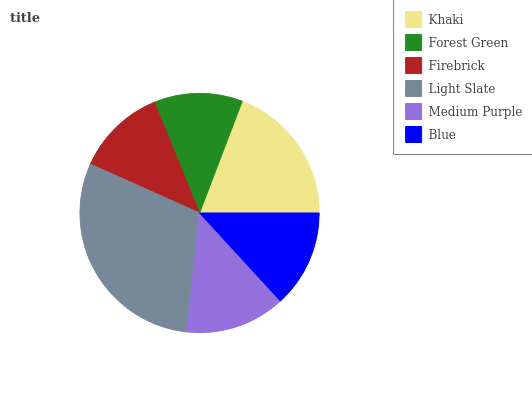Is Forest Green the minimum?
Answer yes or no. Yes. Is Light Slate the maximum?
Answer yes or no. Yes. Is Firebrick the minimum?
Answer yes or no. No. Is Firebrick the maximum?
Answer yes or no. No. Is Firebrick greater than Forest Green?
Answer yes or no. Yes. Is Forest Green less than Firebrick?
Answer yes or no. Yes. Is Forest Green greater than Firebrick?
Answer yes or no. No. Is Firebrick less than Forest Green?
Answer yes or no. No. Is Medium Purple the high median?
Answer yes or no. Yes. Is Blue the low median?
Answer yes or no. Yes. Is Firebrick the high median?
Answer yes or no. No. Is Firebrick the low median?
Answer yes or no. No. 